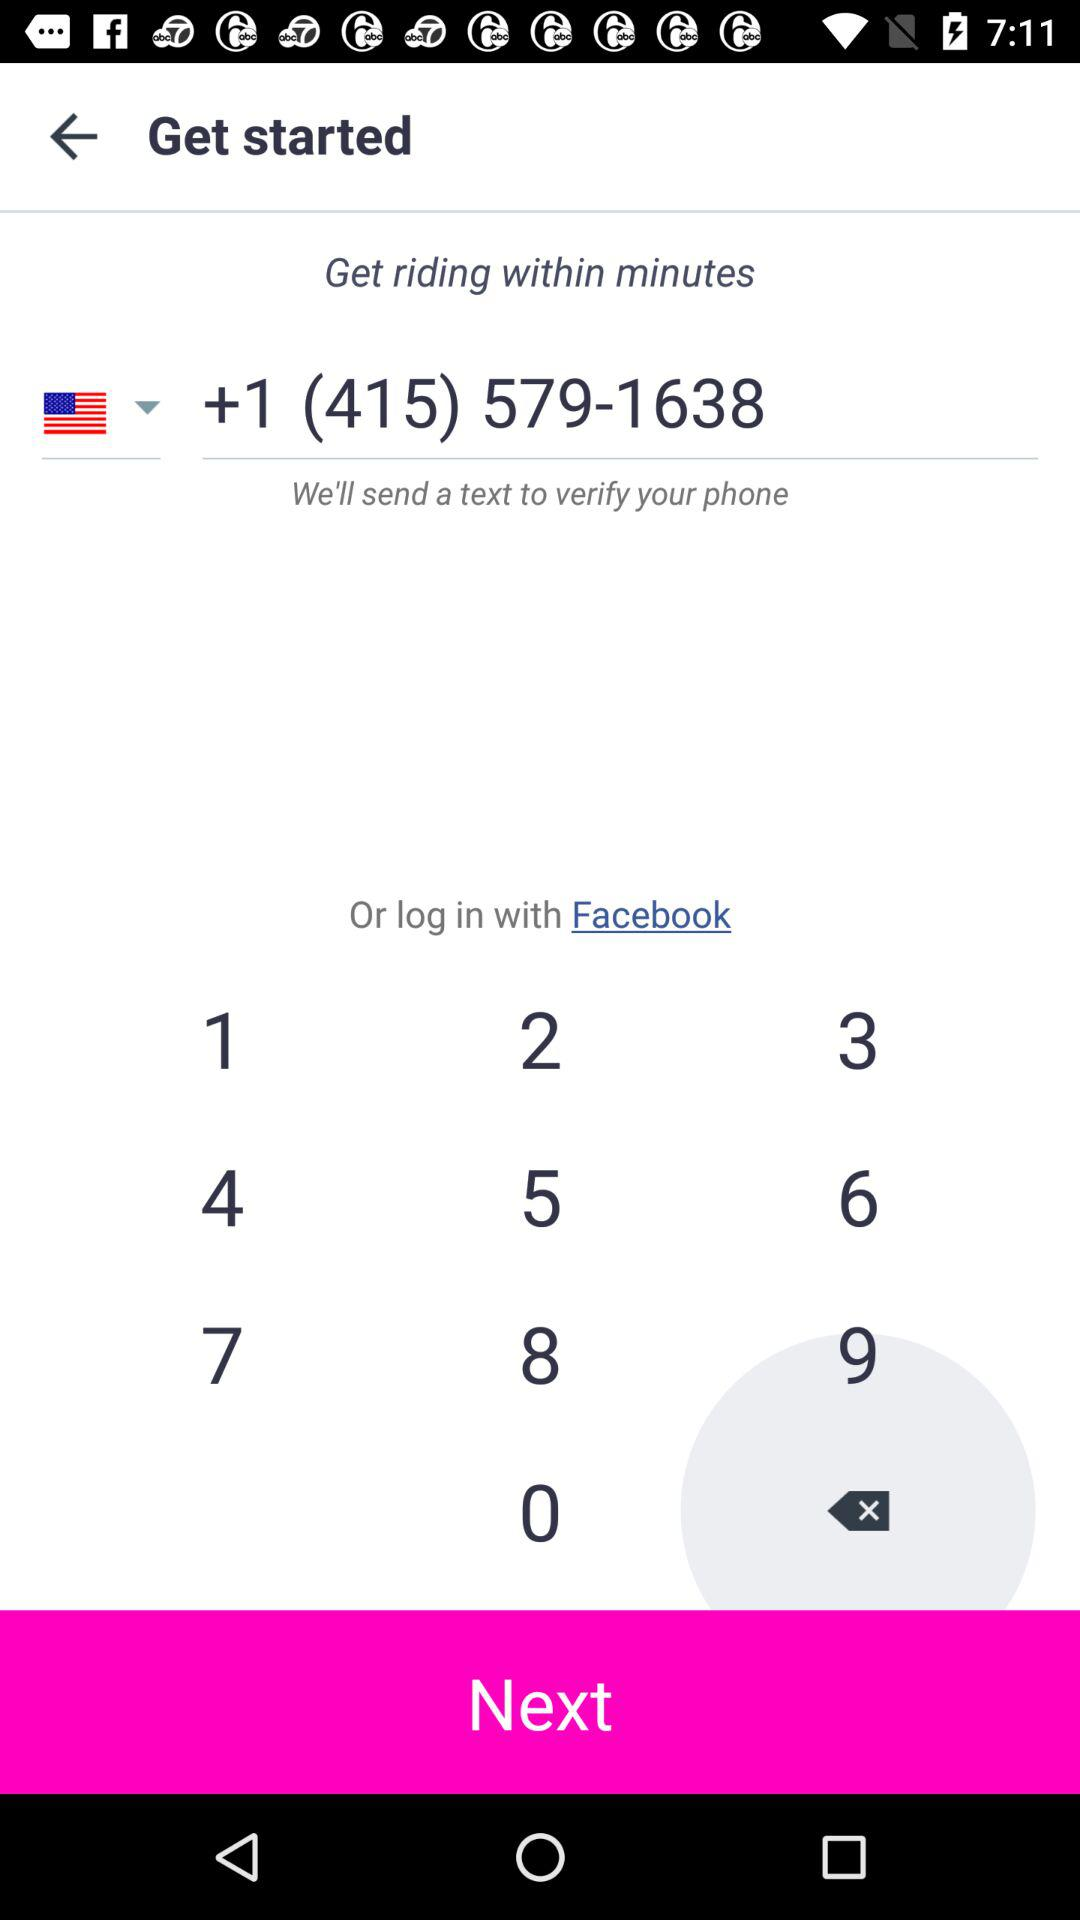What is the phone number? The phone number is +1 (415) 579-1638. 